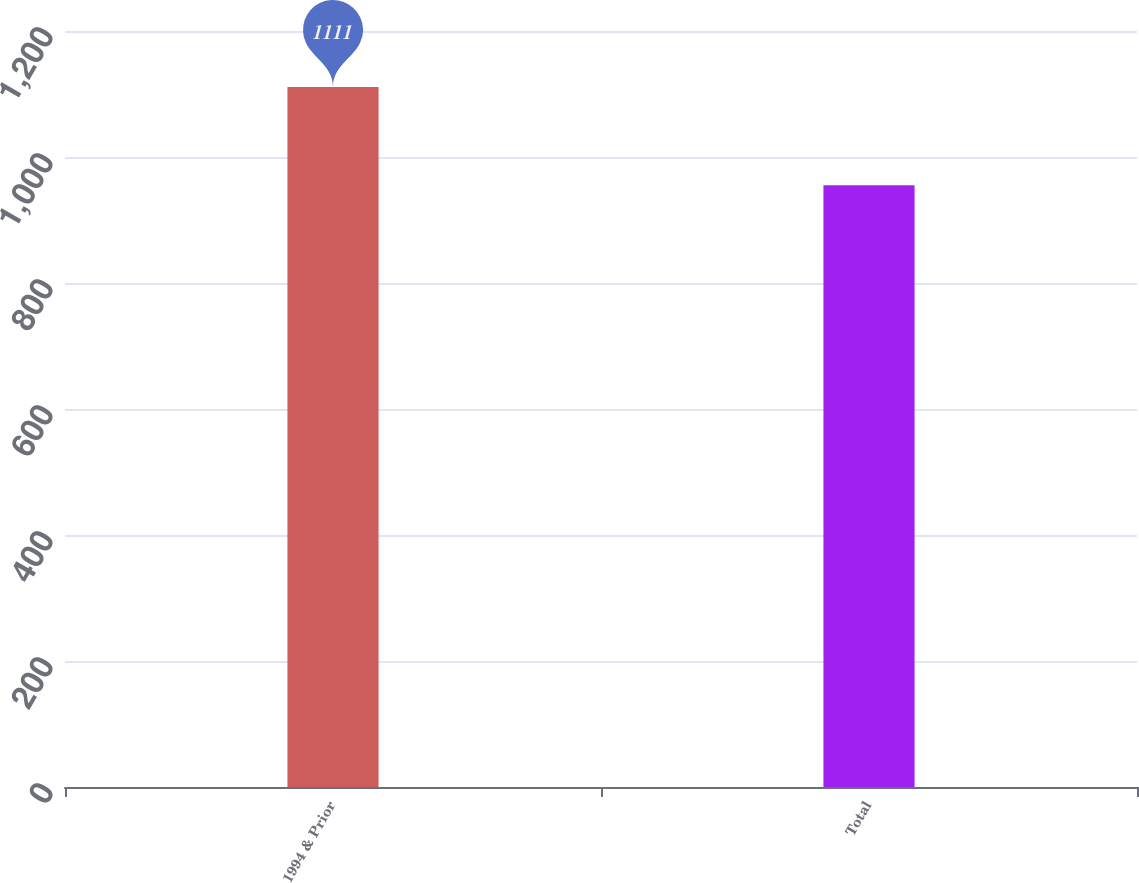Convert chart to OTSL. <chart><loc_0><loc_0><loc_500><loc_500><bar_chart><fcel>1994 & Prior<fcel>Total<nl><fcel>1111<fcel>955<nl></chart> 